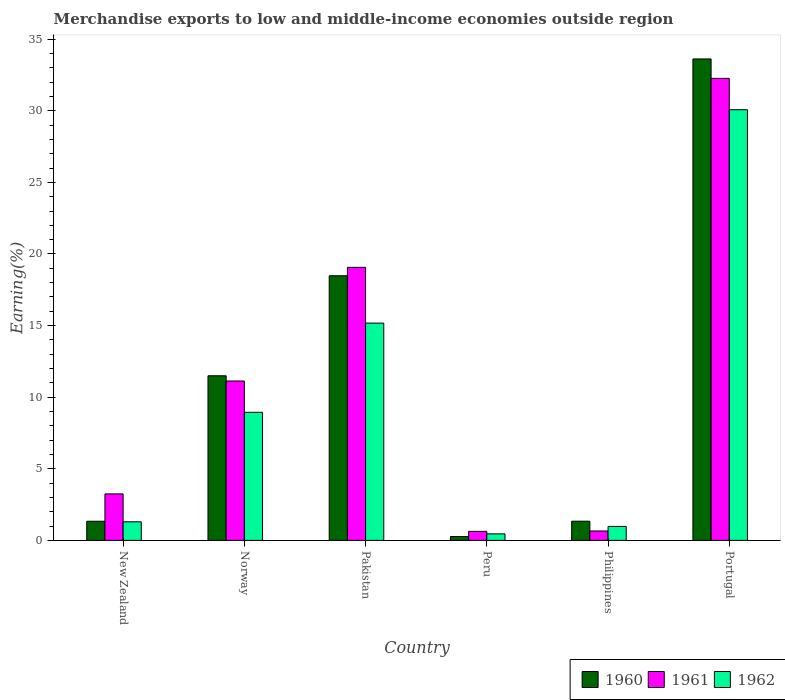How many groups of bars are there?
Your answer should be very brief. 6. Are the number of bars per tick equal to the number of legend labels?
Your response must be concise. Yes. Are the number of bars on each tick of the X-axis equal?
Your answer should be very brief. Yes. How many bars are there on the 5th tick from the left?
Give a very brief answer. 3. How many bars are there on the 2nd tick from the right?
Keep it short and to the point. 3. What is the label of the 5th group of bars from the left?
Offer a terse response. Philippines. What is the percentage of amount earned from merchandise exports in 1960 in Philippines?
Offer a very short reply. 1.34. Across all countries, what is the maximum percentage of amount earned from merchandise exports in 1960?
Ensure brevity in your answer.  33.62. Across all countries, what is the minimum percentage of amount earned from merchandise exports in 1961?
Provide a succinct answer. 0.63. In which country was the percentage of amount earned from merchandise exports in 1962 maximum?
Provide a succinct answer. Portugal. In which country was the percentage of amount earned from merchandise exports in 1961 minimum?
Provide a short and direct response. Peru. What is the total percentage of amount earned from merchandise exports in 1961 in the graph?
Your answer should be very brief. 66.99. What is the difference between the percentage of amount earned from merchandise exports in 1962 in Peru and that in Philippines?
Keep it short and to the point. -0.52. What is the difference between the percentage of amount earned from merchandise exports in 1961 in Portugal and the percentage of amount earned from merchandise exports in 1962 in Peru?
Your answer should be very brief. 31.81. What is the average percentage of amount earned from merchandise exports in 1961 per country?
Your answer should be compact. 11.17. What is the difference between the percentage of amount earned from merchandise exports of/in 1960 and percentage of amount earned from merchandise exports of/in 1961 in Peru?
Your answer should be compact. -0.36. In how many countries, is the percentage of amount earned from merchandise exports in 1961 greater than 10 %?
Provide a short and direct response. 3. What is the ratio of the percentage of amount earned from merchandise exports in 1960 in Norway to that in Philippines?
Your answer should be very brief. 8.57. Is the percentage of amount earned from merchandise exports in 1961 in New Zealand less than that in Pakistan?
Provide a succinct answer. Yes. Is the difference between the percentage of amount earned from merchandise exports in 1960 in Norway and Peru greater than the difference between the percentage of amount earned from merchandise exports in 1961 in Norway and Peru?
Your answer should be compact. Yes. What is the difference between the highest and the second highest percentage of amount earned from merchandise exports in 1961?
Your answer should be very brief. 21.13. What is the difference between the highest and the lowest percentage of amount earned from merchandise exports in 1962?
Offer a terse response. 29.62. Is the sum of the percentage of amount earned from merchandise exports in 1962 in Pakistan and Peru greater than the maximum percentage of amount earned from merchandise exports in 1960 across all countries?
Your response must be concise. No. Is it the case that in every country, the sum of the percentage of amount earned from merchandise exports in 1961 and percentage of amount earned from merchandise exports in 1962 is greater than the percentage of amount earned from merchandise exports in 1960?
Offer a terse response. Yes. How many bars are there?
Give a very brief answer. 18. How many countries are there in the graph?
Your answer should be compact. 6. Does the graph contain any zero values?
Offer a terse response. No. Where does the legend appear in the graph?
Keep it short and to the point. Bottom right. How many legend labels are there?
Keep it short and to the point. 3. What is the title of the graph?
Ensure brevity in your answer.  Merchandise exports to low and middle-income economies outside region. Does "1998" appear as one of the legend labels in the graph?
Provide a short and direct response. No. What is the label or title of the X-axis?
Provide a succinct answer. Country. What is the label or title of the Y-axis?
Your response must be concise. Earning(%). What is the Earning(%) in 1960 in New Zealand?
Ensure brevity in your answer.  1.34. What is the Earning(%) in 1961 in New Zealand?
Provide a short and direct response. 3.25. What is the Earning(%) in 1962 in New Zealand?
Make the answer very short. 1.3. What is the Earning(%) of 1960 in Norway?
Offer a terse response. 11.5. What is the Earning(%) of 1961 in Norway?
Your answer should be very brief. 11.13. What is the Earning(%) in 1962 in Norway?
Give a very brief answer. 8.94. What is the Earning(%) in 1960 in Pakistan?
Provide a short and direct response. 18.48. What is the Earning(%) of 1961 in Pakistan?
Make the answer very short. 19.07. What is the Earning(%) of 1962 in Pakistan?
Keep it short and to the point. 15.17. What is the Earning(%) in 1960 in Peru?
Offer a terse response. 0.27. What is the Earning(%) in 1961 in Peru?
Offer a very short reply. 0.63. What is the Earning(%) of 1962 in Peru?
Ensure brevity in your answer.  0.46. What is the Earning(%) of 1960 in Philippines?
Offer a terse response. 1.34. What is the Earning(%) of 1961 in Philippines?
Your response must be concise. 0.66. What is the Earning(%) in 1962 in Philippines?
Offer a terse response. 0.98. What is the Earning(%) in 1960 in Portugal?
Ensure brevity in your answer.  33.62. What is the Earning(%) of 1961 in Portugal?
Give a very brief answer. 32.26. What is the Earning(%) in 1962 in Portugal?
Provide a succinct answer. 30.07. Across all countries, what is the maximum Earning(%) in 1960?
Provide a short and direct response. 33.62. Across all countries, what is the maximum Earning(%) of 1961?
Provide a short and direct response. 32.26. Across all countries, what is the maximum Earning(%) in 1962?
Keep it short and to the point. 30.07. Across all countries, what is the minimum Earning(%) of 1960?
Ensure brevity in your answer.  0.27. Across all countries, what is the minimum Earning(%) in 1961?
Ensure brevity in your answer.  0.63. Across all countries, what is the minimum Earning(%) in 1962?
Your answer should be compact. 0.46. What is the total Earning(%) of 1960 in the graph?
Your answer should be very brief. 66.54. What is the total Earning(%) of 1961 in the graph?
Provide a short and direct response. 66.99. What is the total Earning(%) of 1962 in the graph?
Offer a very short reply. 56.92. What is the difference between the Earning(%) in 1960 in New Zealand and that in Norway?
Give a very brief answer. -10.16. What is the difference between the Earning(%) in 1961 in New Zealand and that in Norway?
Your response must be concise. -7.88. What is the difference between the Earning(%) in 1962 in New Zealand and that in Norway?
Your response must be concise. -7.65. What is the difference between the Earning(%) in 1960 in New Zealand and that in Pakistan?
Give a very brief answer. -17.14. What is the difference between the Earning(%) in 1961 in New Zealand and that in Pakistan?
Make the answer very short. -15.82. What is the difference between the Earning(%) of 1962 in New Zealand and that in Pakistan?
Provide a short and direct response. -13.88. What is the difference between the Earning(%) of 1960 in New Zealand and that in Peru?
Offer a very short reply. 1.07. What is the difference between the Earning(%) in 1961 in New Zealand and that in Peru?
Offer a very short reply. 2.62. What is the difference between the Earning(%) in 1962 in New Zealand and that in Peru?
Offer a terse response. 0.84. What is the difference between the Earning(%) in 1960 in New Zealand and that in Philippines?
Your answer should be compact. -0. What is the difference between the Earning(%) in 1961 in New Zealand and that in Philippines?
Your answer should be very brief. 2.59. What is the difference between the Earning(%) of 1962 in New Zealand and that in Philippines?
Keep it short and to the point. 0.32. What is the difference between the Earning(%) of 1960 in New Zealand and that in Portugal?
Provide a short and direct response. -32.28. What is the difference between the Earning(%) in 1961 in New Zealand and that in Portugal?
Ensure brevity in your answer.  -29.02. What is the difference between the Earning(%) in 1962 in New Zealand and that in Portugal?
Give a very brief answer. -28.78. What is the difference between the Earning(%) in 1960 in Norway and that in Pakistan?
Make the answer very short. -6.98. What is the difference between the Earning(%) of 1961 in Norway and that in Pakistan?
Keep it short and to the point. -7.94. What is the difference between the Earning(%) in 1962 in Norway and that in Pakistan?
Provide a short and direct response. -6.23. What is the difference between the Earning(%) in 1960 in Norway and that in Peru?
Ensure brevity in your answer.  11.23. What is the difference between the Earning(%) of 1961 in Norway and that in Peru?
Offer a very short reply. 10.5. What is the difference between the Earning(%) of 1962 in Norway and that in Peru?
Make the answer very short. 8.49. What is the difference between the Earning(%) of 1960 in Norway and that in Philippines?
Keep it short and to the point. 10.15. What is the difference between the Earning(%) in 1961 in Norway and that in Philippines?
Provide a succinct answer. 10.47. What is the difference between the Earning(%) in 1962 in Norway and that in Philippines?
Offer a terse response. 7.97. What is the difference between the Earning(%) of 1960 in Norway and that in Portugal?
Give a very brief answer. -22.12. What is the difference between the Earning(%) in 1961 in Norway and that in Portugal?
Make the answer very short. -21.13. What is the difference between the Earning(%) of 1962 in Norway and that in Portugal?
Your answer should be very brief. -21.13. What is the difference between the Earning(%) in 1960 in Pakistan and that in Peru?
Make the answer very short. 18.21. What is the difference between the Earning(%) of 1961 in Pakistan and that in Peru?
Offer a terse response. 18.44. What is the difference between the Earning(%) in 1962 in Pakistan and that in Peru?
Your answer should be very brief. 14.72. What is the difference between the Earning(%) of 1960 in Pakistan and that in Philippines?
Keep it short and to the point. 17.14. What is the difference between the Earning(%) in 1961 in Pakistan and that in Philippines?
Offer a terse response. 18.41. What is the difference between the Earning(%) of 1962 in Pakistan and that in Philippines?
Ensure brevity in your answer.  14.2. What is the difference between the Earning(%) of 1960 in Pakistan and that in Portugal?
Ensure brevity in your answer.  -15.14. What is the difference between the Earning(%) in 1961 in Pakistan and that in Portugal?
Your response must be concise. -13.2. What is the difference between the Earning(%) of 1962 in Pakistan and that in Portugal?
Your answer should be compact. -14.9. What is the difference between the Earning(%) of 1960 in Peru and that in Philippines?
Your answer should be very brief. -1.07. What is the difference between the Earning(%) in 1961 in Peru and that in Philippines?
Offer a very short reply. -0.03. What is the difference between the Earning(%) in 1962 in Peru and that in Philippines?
Provide a short and direct response. -0.52. What is the difference between the Earning(%) in 1960 in Peru and that in Portugal?
Offer a very short reply. -33.35. What is the difference between the Earning(%) in 1961 in Peru and that in Portugal?
Offer a very short reply. -31.63. What is the difference between the Earning(%) of 1962 in Peru and that in Portugal?
Your response must be concise. -29.62. What is the difference between the Earning(%) in 1960 in Philippines and that in Portugal?
Provide a short and direct response. -32.28. What is the difference between the Earning(%) of 1961 in Philippines and that in Portugal?
Keep it short and to the point. -31.61. What is the difference between the Earning(%) of 1962 in Philippines and that in Portugal?
Provide a short and direct response. -29.1. What is the difference between the Earning(%) in 1960 in New Zealand and the Earning(%) in 1961 in Norway?
Your answer should be compact. -9.79. What is the difference between the Earning(%) in 1960 in New Zealand and the Earning(%) in 1962 in Norway?
Provide a succinct answer. -7.61. What is the difference between the Earning(%) in 1961 in New Zealand and the Earning(%) in 1962 in Norway?
Make the answer very short. -5.7. What is the difference between the Earning(%) of 1960 in New Zealand and the Earning(%) of 1961 in Pakistan?
Ensure brevity in your answer.  -17.73. What is the difference between the Earning(%) in 1960 in New Zealand and the Earning(%) in 1962 in Pakistan?
Offer a very short reply. -13.84. What is the difference between the Earning(%) of 1961 in New Zealand and the Earning(%) of 1962 in Pakistan?
Your answer should be compact. -11.93. What is the difference between the Earning(%) of 1960 in New Zealand and the Earning(%) of 1961 in Peru?
Provide a short and direct response. 0.71. What is the difference between the Earning(%) of 1960 in New Zealand and the Earning(%) of 1962 in Peru?
Keep it short and to the point. 0.88. What is the difference between the Earning(%) of 1961 in New Zealand and the Earning(%) of 1962 in Peru?
Your answer should be compact. 2.79. What is the difference between the Earning(%) of 1960 in New Zealand and the Earning(%) of 1961 in Philippines?
Your response must be concise. 0.68. What is the difference between the Earning(%) of 1960 in New Zealand and the Earning(%) of 1962 in Philippines?
Keep it short and to the point. 0.36. What is the difference between the Earning(%) of 1961 in New Zealand and the Earning(%) of 1962 in Philippines?
Keep it short and to the point. 2.27. What is the difference between the Earning(%) of 1960 in New Zealand and the Earning(%) of 1961 in Portugal?
Provide a succinct answer. -30.93. What is the difference between the Earning(%) of 1960 in New Zealand and the Earning(%) of 1962 in Portugal?
Make the answer very short. -28.74. What is the difference between the Earning(%) of 1961 in New Zealand and the Earning(%) of 1962 in Portugal?
Offer a terse response. -26.83. What is the difference between the Earning(%) in 1960 in Norway and the Earning(%) in 1961 in Pakistan?
Provide a succinct answer. -7.57. What is the difference between the Earning(%) in 1960 in Norway and the Earning(%) in 1962 in Pakistan?
Provide a succinct answer. -3.68. What is the difference between the Earning(%) of 1961 in Norway and the Earning(%) of 1962 in Pakistan?
Offer a terse response. -4.04. What is the difference between the Earning(%) of 1960 in Norway and the Earning(%) of 1961 in Peru?
Your answer should be very brief. 10.87. What is the difference between the Earning(%) of 1960 in Norway and the Earning(%) of 1962 in Peru?
Keep it short and to the point. 11.04. What is the difference between the Earning(%) of 1961 in Norway and the Earning(%) of 1962 in Peru?
Give a very brief answer. 10.67. What is the difference between the Earning(%) in 1960 in Norway and the Earning(%) in 1961 in Philippines?
Offer a terse response. 10.84. What is the difference between the Earning(%) in 1960 in Norway and the Earning(%) in 1962 in Philippines?
Your answer should be very brief. 10.52. What is the difference between the Earning(%) of 1961 in Norway and the Earning(%) of 1962 in Philippines?
Ensure brevity in your answer.  10.15. What is the difference between the Earning(%) in 1960 in Norway and the Earning(%) in 1961 in Portugal?
Provide a short and direct response. -20.77. What is the difference between the Earning(%) of 1960 in Norway and the Earning(%) of 1962 in Portugal?
Keep it short and to the point. -18.58. What is the difference between the Earning(%) in 1961 in Norway and the Earning(%) in 1962 in Portugal?
Make the answer very short. -18.94. What is the difference between the Earning(%) in 1960 in Pakistan and the Earning(%) in 1961 in Peru?
Ensure brevity in your answer.  17.85. What is the difference between the Earning(%) of 1960 in Pakistan and the Earning(%) of 1962 in Peru?
Make the answer very short. 18.02. What is the difference between the Earning(%) in 1961 in Pakistan and the Earning(%) in 1962 in Peru?
Give a very brief answer. 18.61. What is the difference between the Earning(%) in 1960 in Pakistan and the Earning(%) in 1961 in Philippines?
Keep it short and to the point. 17.82. What is the difference between the Earning(%) in 1960 in Pakistan and the Earning(%) in 1962 in Philippines?
Offer a very short reply. 17.5. What is the difference between the Earning(%) in 1961 in Pakistan and the Earning(%) in 1962 in Philippines?
Offer a very short reply. 18.09. What is the difference between the Earning(%) of 1960 in Pakistan and the Earning(%) of 1961 in Portugal?
Your answer should be very brief. -13.79. What is the difference between the Earning(%) of 1960 in Pakistan and the Earning(%) of 1962 in Portugal?
Your answer should be very brief. -11.6. What is the difference between the Earning(%) of 1961 in Pakistan and the Earning(%) of 1962 in Portugal?
Make the answer very short. -11.01. What is the difference between the Earning(%) of 1960 in Peru and the Earning(%) of 1961 in Philippines?
Ensure brevity in your answer.  -0.39. What is the difference between the Earning(%) of 1960 in Peru and the Earning(%) of 1962 in Philippines?
Offer a terse response. -0.71. What is the difference between the Earning(%) in 1961 in Peru and the Earning(%) in 1962 in Philippines?
Offer a terse response. -0.35. What is the difference between the Earning(%) of 1960 in Peru and the Earning(%) of 1961 in Portugal?
Provide a succinct answer. -32. What is the difference between the Earning(%) in 1960 in Peru and the Earning(%) in 1962 in Portugal?
Offer a terse response. -29.81. What is the difference between the Earning(%) in 1961 in Peru and the Earning(%) in 1962 in Portugal?
Your answer should be compact. -29.44. What is the difference between the Earning(%) in 1960 in Philippines and the Earning(%) in 1961 in Portugal?
Offer a very short reply. -30.92. What is the difference between the Earning(%) of 1960 in Philippines and the Earning(%) of 1962 in Portugal?
Ensure brevity in your answer.  -28.73. What is the difference between the Earning(%) in 1961 in Philippines and the Earning(%) in 1962 in Portugal?
Keep it short and to the point. -29.42. What is the average Earning(%) in 1960 per country?
Provide a short and direct response. 11.09. What is the average Earning(%) in 1961 per country?
Your answer should be compact. 11.17. What is the average Earning(%) in 1962 per country?
Your response must be concise. 9.49. What is the difference between the Earning(%) in 1960 and Earning(%) in 1961 in New Zealand?
Keep it short and to the point. -1.91. What is the difference between the Earning(%) of 1960 and Earning(%) of 1962 in New Zealand?
Offer a very short reply. 0.04. What is the difference between the Earning(%) in 1961 and Earning(%) in 1962 in New Zealand?
Offer a terse response. 1.95. What is the difference between the Earning(%) of 1960 and Earning(%) of 1961 in Norway?
Ensure brevity in your answer.  0.37. What is the difference between the Earning(%) in 1960 and Earning(%) in 1962 in Norway?
Offer a very short reply. 2.55. What is the difference between the Earning(%) in 1961 and Earning(%) in 1962 in Norway?
Your response must be concise. 2.19. What is the difference between the Earning(%) of 1960 and Earning(%) of 1961 in Pakistan?
Your answer should be very brief. -0.59. What is the difference between the Earning(%) of 1960 and Earning(%) of 1962 in Pakistan?
Provide a short and direct response. 3.31. What is the difference between the Earning(%) in 1961 and Earning(%) in 1962 in Pakistan?
Make the answer very short. 3.89. What is the difference between the Earning(%) in 1960 and Earning(%) in 1961 in Peru?
Provide a succinct answer. -0.36. What is the difference between the Earning(%) of 1960 and Earning(%) of 1962 in Peru?
Offer a very short reply. -0.19. What is the difference between the Earning(%) in 1961 and Earning(%) in 1962 in Peru?
Make the answer very short. 0.17. What is the difference between the Earning(%) in 1960 and Earning(%) in 1961 in Philippines?
Your response must be concise. 0.68. What is the difference between the Earning(%) of 1960 and Earning(%) of 1962 in Philippines?
Offer a terse response. 0.36. What is the difference between the Earning(%) of 1961 and Earning(%) of 1962 in Philippines?
Offer a terse response. -0.32. What is the difference between the Earning(%) in 1960 and Earning(%) in 1961 in Portugal?
Your response must be concise. 1.36. What is the difference between the Earning(%) in 1960 and Earning(%) in 1962 in Portugal?
Ensure brevity in your answer.  3.54. What is the difference between the Earning(%) of 1961 and Earning(%) of 1962 in Portugal?
Your answer should be compact. 2.19. What is the ratio of the Earning(%) of 1960 in New Zealand to that in Norway?
Your answer should be compact. 0.12. What is the ratio of the Earning(%) in 1961 in New Zealand to that in Norway?
Your answer should be compact. 0.29. What is the ratio of the Earning(%) of 1962 in New Zealand to that in Norway?
Keep it short and to the point. 0.15. What is the ratio of the Earning(%) in 1960 in New Zealand to that in Pakistan?
Your response must be concise. 0.07. What is the ratio of the Earning(%) in 1961 in New Zealand to that in Pakistan?
Your answer should be very brief. 0.17. What is the ratio of the Earning(%) in 1962 in New Zealand to that in Pakistan?
Offer a very short reply. 0.09. What is the ratio of the Earning(%) of 1960 in New Zealand to that in Peru?
Ensure brevity in your answer.  4.97. What is the ratio of the Earning(%) of 1961 in New Zealand to that in Peru?
Your response must be concise. 5.16. What is the ratio of the Earning(%) in 1962 in New Zealand to that in Peru?
Provide a short and direct response. 2.84. What is the ratio of the Earning(%) in 1961 in New Zealand to that in Philippines?
Your answer should be very brief. 4.95. What is the ratio of the Earning(%) in 1962 in New Zealand to that in Philippines?
Offer a very short reply. 1.33. What is the ratio of the Earning(%) in 1960 in New Zealand to that in Portugal?
Your answer should be compact. 0.04. What is the ratio of the Earning(%) in 1961 in New Zealand to that in Portugal?
Your answer should be compact. 0.1. What is the ratio of the Earning(%) in 1962 in New Zealand to that in Portugal?
Your response must be concise. 0.04. What is the ratio of the Earning(%) of 1960 in Norway to that in Pakistan?
Make the answer very short. 0.62. What is the ratio of the Earning(%) of 1961 in Norway to that in Pakistan?
Your answer should be compact. 0.58. What is the ratio of the Earning(%) of 1962 in Norway to that in Pakistan?
Your response must be concise. 0.59. What is the ratio of the Earning(%) of 1960 in Norway to that in Peru?
Offer a very short reply. 42.72. What is the ratio of the Earning(%) in 1961 in Norway to that in Peru?
Your response must be concise. 17.67. What is the ratio of the Earning(%) in 1962 in Norway to that in Peru?
Ensure brevity in your answer.  19.59. What is the ratio of the Earning(%) of 1960 in Norway to that in Philippines?
Make the answer very short. 8.57. What is the ratio of the Earning(%) in 1961 in Norway to that in Philippines?
Ensure brevity in your answer.  16.96. What is the ratio of the Earning(%) of 1962 in Norway to that in Philippines?
Your answer should be very brief. 9.16. What is the ratio of the Earning(%) of 1960 in Norway to that in Portugal?
Make the answer very short. 0.34. What is the ratio of the Earning(%) in 1961 in Norway to that in Portugal?
Offer a very short reply. 0.34. What is the ratio of the Earning(%) in 1962 in Norway to that in Portugal?
Your answer should be compact. 0.3. What is the ratio of the Earning(%) of 1960 in Pakistan to that in Peru?
Ensure brevity in your answer.  68.67. What is the ratio of the Earning(%) of 1961 in Pakistan to that in Peru?
Provide a succinct answer. 30.27. What is the ratio of the Earning(%) of 1962 in Pakistan to that in Peru?
Ensure brevity in your answer.  33.24. What is the ratio of the Earning(%) of 1960 in Pakistan to that in Philippines?
Your response must be concise. 13.78. What is the ratio of the Earning(%) of 1961 in Pakistan to that in Philippines?
Your response must be concise. 29.05. What is the ratio of the Earning(%) of 1962 in Pakistan to that in Philippines?
Keep it short and to the point. 15.54. What is the ratio of the Earning(%) in 1960 in Pakistan to that in Portugal?
Your response must be concise. 0.55. What is the ratio of the Earning(%) in 1961 in Pakistan to that in Portugal?
Ensure brevity in your answer.  0.59. What is the ratio of the Earning(%) of 1962 in Pakistan to that in Portugal?
Provide a short and direct response. 0.5. What is the ratio of the Earning(%) of 1960 in Peru to that in Philippines?
Provide a short and direct response. 0.2. What is the ratio of the Earning(%) in 1961 in Peru to that in Philippines?
Make the answer very short. 0.96. What is the ratio of the Earning(%) in 1962 in Peru to that in Philippines?
Your answer should be compact. 0.47. What is the ratio of the Earning(%) of 1960 in Peru to that in Portugal?
Make the answer very short. 0.01. What is the ratio of the Earning(%) of 1961 in Peru to that in Portugal?
Your answer should be very brief. 0.02. What is the ratio of the Earning(%) of 1962 in Peru to that in Portugal?
Your answer should be compact. 0.02. What is the ratio of the Earning(%) in 1960 in Philippines to that in Portugal?
Give a very brief answer. 0.04. What is the ratio of the Earning(%) in 1961 in Philippines to that in Portugal?
Offer a very short reply. 0.02. What is the ratio of the Earning(%) in 1962 in Philippines to that in Portugal?
Your answer should be very brief. 0.03. What is the difference between the highest and the second highest Earning(%) of 1960?
Your answer should be very brief. 15.14. What is the difference between the highest and the second highest Earning(%) of 1961?
Keep it short and to the point. 13.2. What is the difference between the highest and the second highest Earning(%) in 1962?
Make the answer very short. 14.9. What is the difference between the highest and the lowest Earning(%) of 1960?
Make the answer very short. 33.35. What is the difference between the highest and the lowest Earning(%) of 1961?
Your answer should be very brief. 31.63. What is the difference between the highest and the lowest Earning(%) of 1962?
Your answer should be compact. 29.62. 